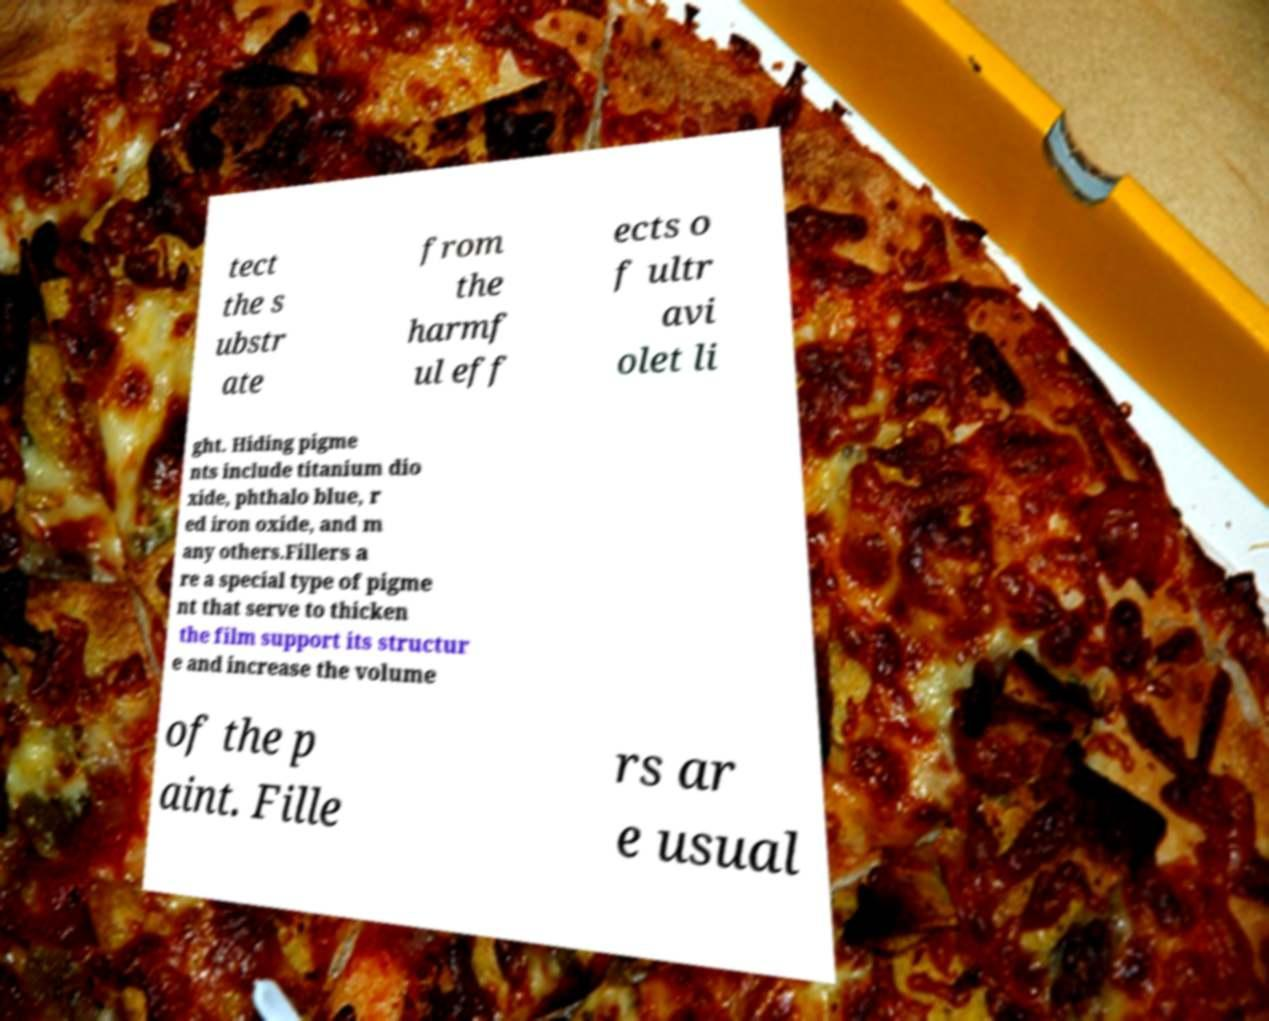Please identify and transcribe the text found in this image. tect the s ubstr ate from the harmf ul eff ects o f ultr avi olet li ght. Hiding pigme nts include titanium dio xide, phthalo blue, r ed iron oxide, and m any others.Fillers a re a special type of pigme nt that serve to thicken the film support its structur e and increase the volume of the p aint. Fille rs ar e usual 